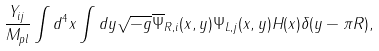Convert formula to latex. <formula><loc_0><loc_0><loc_500><loc_500>\frac { Y _ { i j } } { M _ { p l } } \int d ^ { 4 } x \int d y \sqrt { - g } \overline { \Psi } _ { R , i } ( x , y ) \Psi _ { L , j } ( x , y ) H ( x ) \delta ( y - \pi R ) ,</formula> 